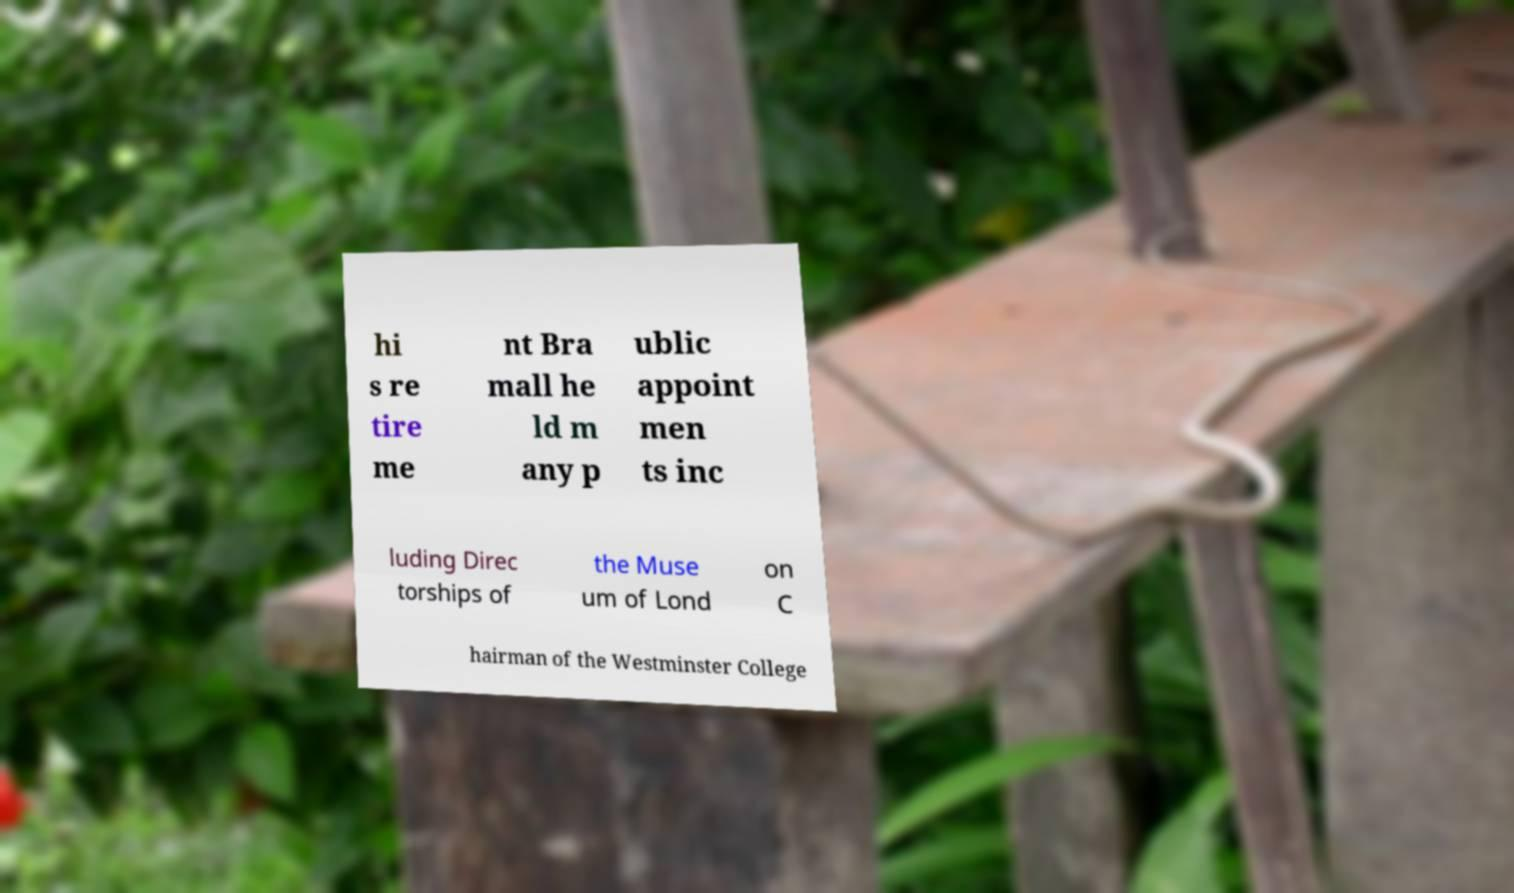There's text embedded in this image that I need extracted. Can you transcribe it verbatim? hi s re tire me nt Bra mall he ld m any p ublic appoint men ts inc luding Direc torships of the Muse um of Lond on C hairman of the Westminster College 